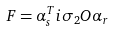Convert formula to latex. <formula><loc_0><loc_0><loc_500><loc_500>F = \alpha ^ { T } _ { s } i \sigma _ { 2 } O \alpha _ { r }</formula> 